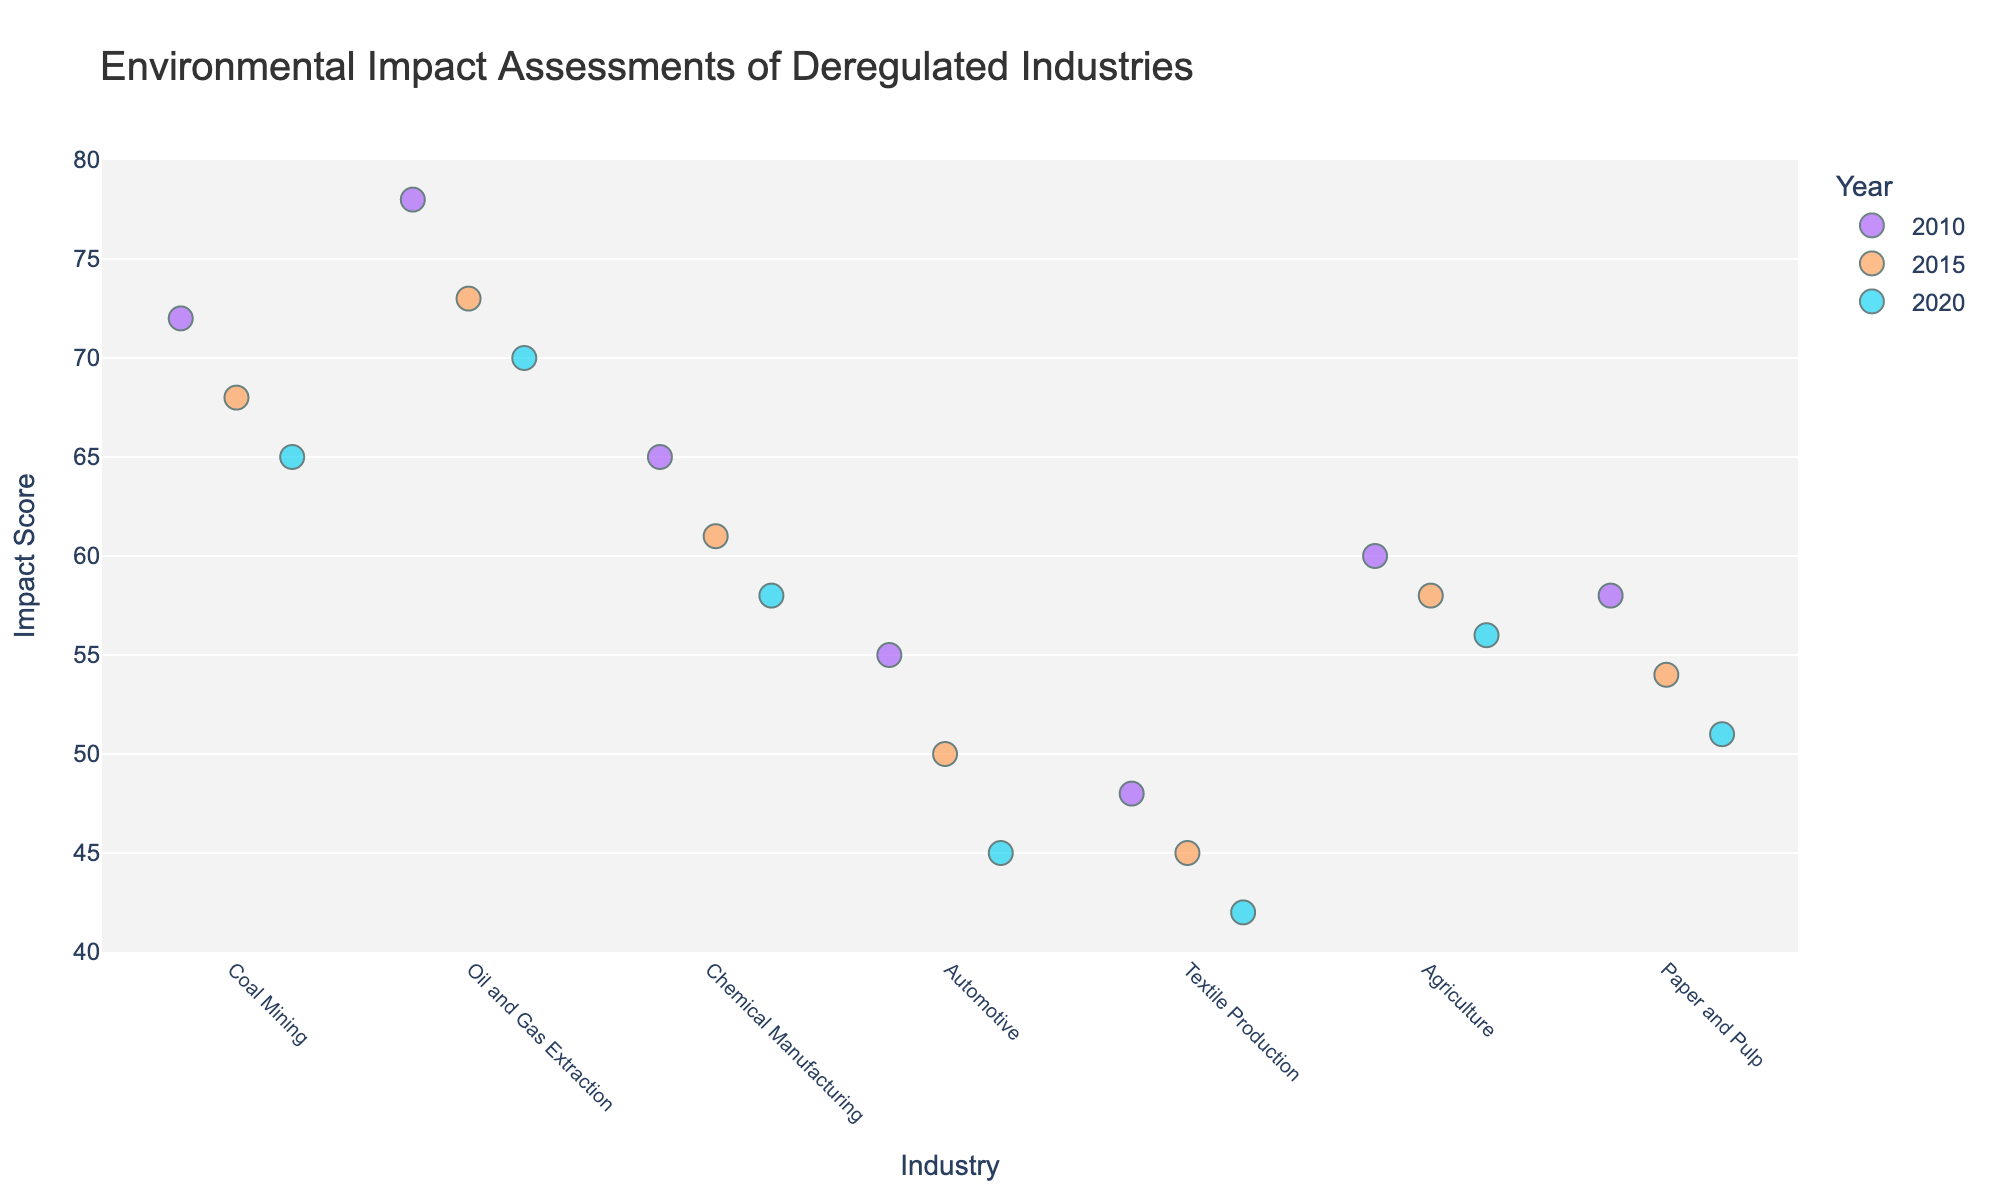What is the title of the figure? The title is usually found at the top of the figure. In this case, it is clearly labeled as "Environmental Impact Assessments of Deregulated Industries."
Answer: Environmental Impact Assessments of Deregulated Industries Which industry has the highest environmental impact score in 2020? By looking at the data points marked with a distinct color representing the year 2020, the highest environmental impact score can be seen in the Oil and Gas Extraction industry.
Answer: Oil and Gas Extraction What is the range of the y-axis? The y-axis range can be observed along the left side of the plot. It starts at 40 and ends at 80.
Answer: 40 to 80 How has the environmental impact score for Coal Mining changed from 2010 to 2020? First, locate the data points for Coal Mining. The scores for the years 2010, 2015, and 2020 are 72, 68, and 65, respectively. This trend shows a decrease in the environmental impact score over the decade.
Answer: Decreased Which industry showed the least improvement in its environmental impact score from 2010 to 2020? Calculate the difference in environmental impact scores for each industry from 2010 to 2020 and compare them. The Textile Production industry decreased from 48 in 2010 to 42 in 2020, which is a change of 6, the least improvement among all industries.
Answer: Textile Production How many industries are assessed in this figure? Count the unique categories listed on the x-axis (Industries). They are Coal Mining, Oil and Gas Extraction, Chemical Manufacturing, Automotive, Textile Production, Agriculture, and Paper and Pulp.
Answer: 7 What color represents the data points for the year 2015? Identify the color legend provided, which maps years to colors. The data points for the year 2015 are in orange.
Answer: Orange Which industry has the largest reduction in environmental impact score between 2010 and 2020? Calculate the score differences for each industry between 2010 and 2020. The Automotive industry shows the largest reduction, from 55 in 2010 to 45 in 2020, resulting in a reduction of 10.
Answer: Automotive What is the average environmental impact score for Agriculture over the years? The scores for Agriculture in 2010, 2015, and 2020 are 60, 58, and 56. To find the average: (60 + 58 + 56) / 3 = 58.
Answer: 58 How do the environmental impact scores for Chemical Manufacturing in 2010 compare to 2020? Compare the scores for Chemical Manufacturing in the respective years. In 2010, the score is 65, and in 2020, it is 58, indicating a decrease.
Answer: Decreased 